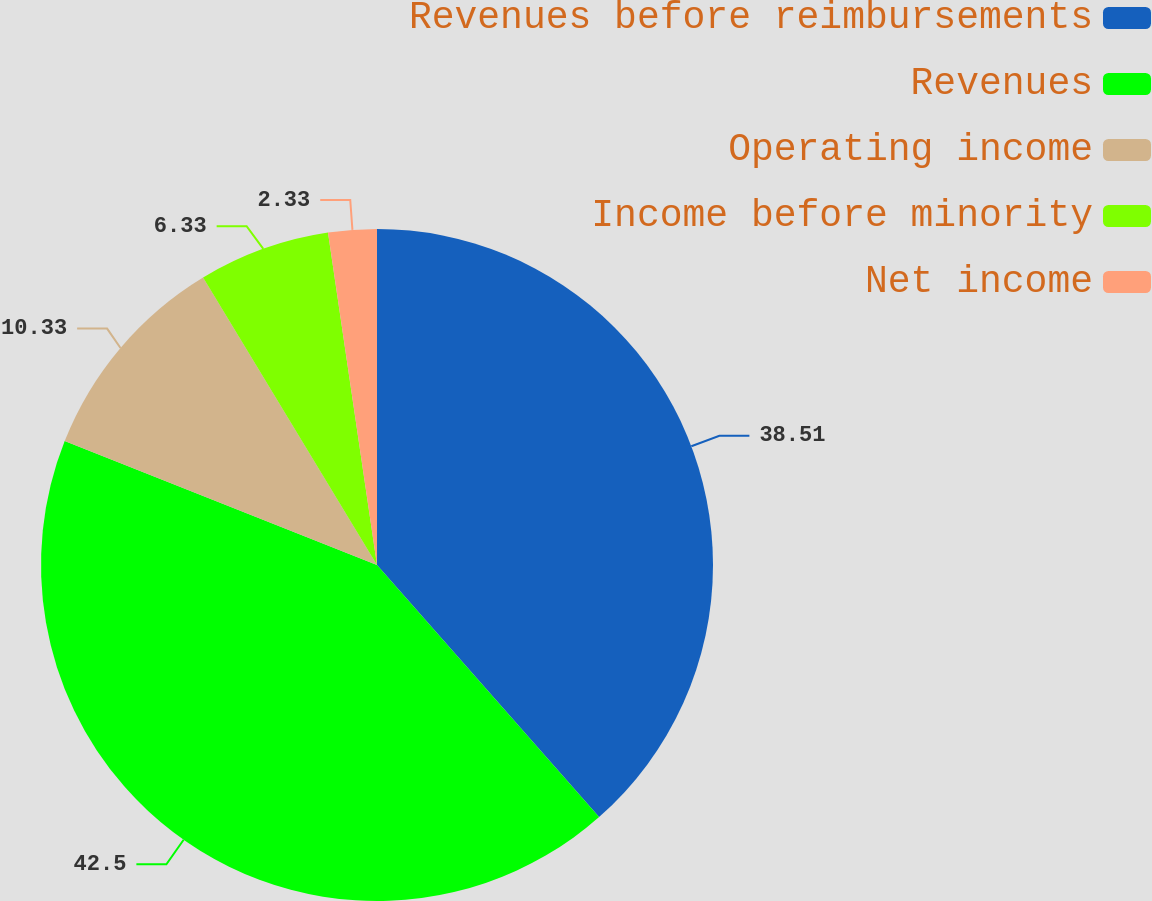<chart> <loc_0><loc_0><loc_500><loc_500><pie_chart><fcel>Revenues before reimbursements<fcel>Revenues<fcel>Operating income<fcel>Income before minority<fcel>Net income<nl><fcel>38.51%<fcel>42.51%<fcel>10.33%<fcel>6.33%<fcel>2.33%<nl></chart> 